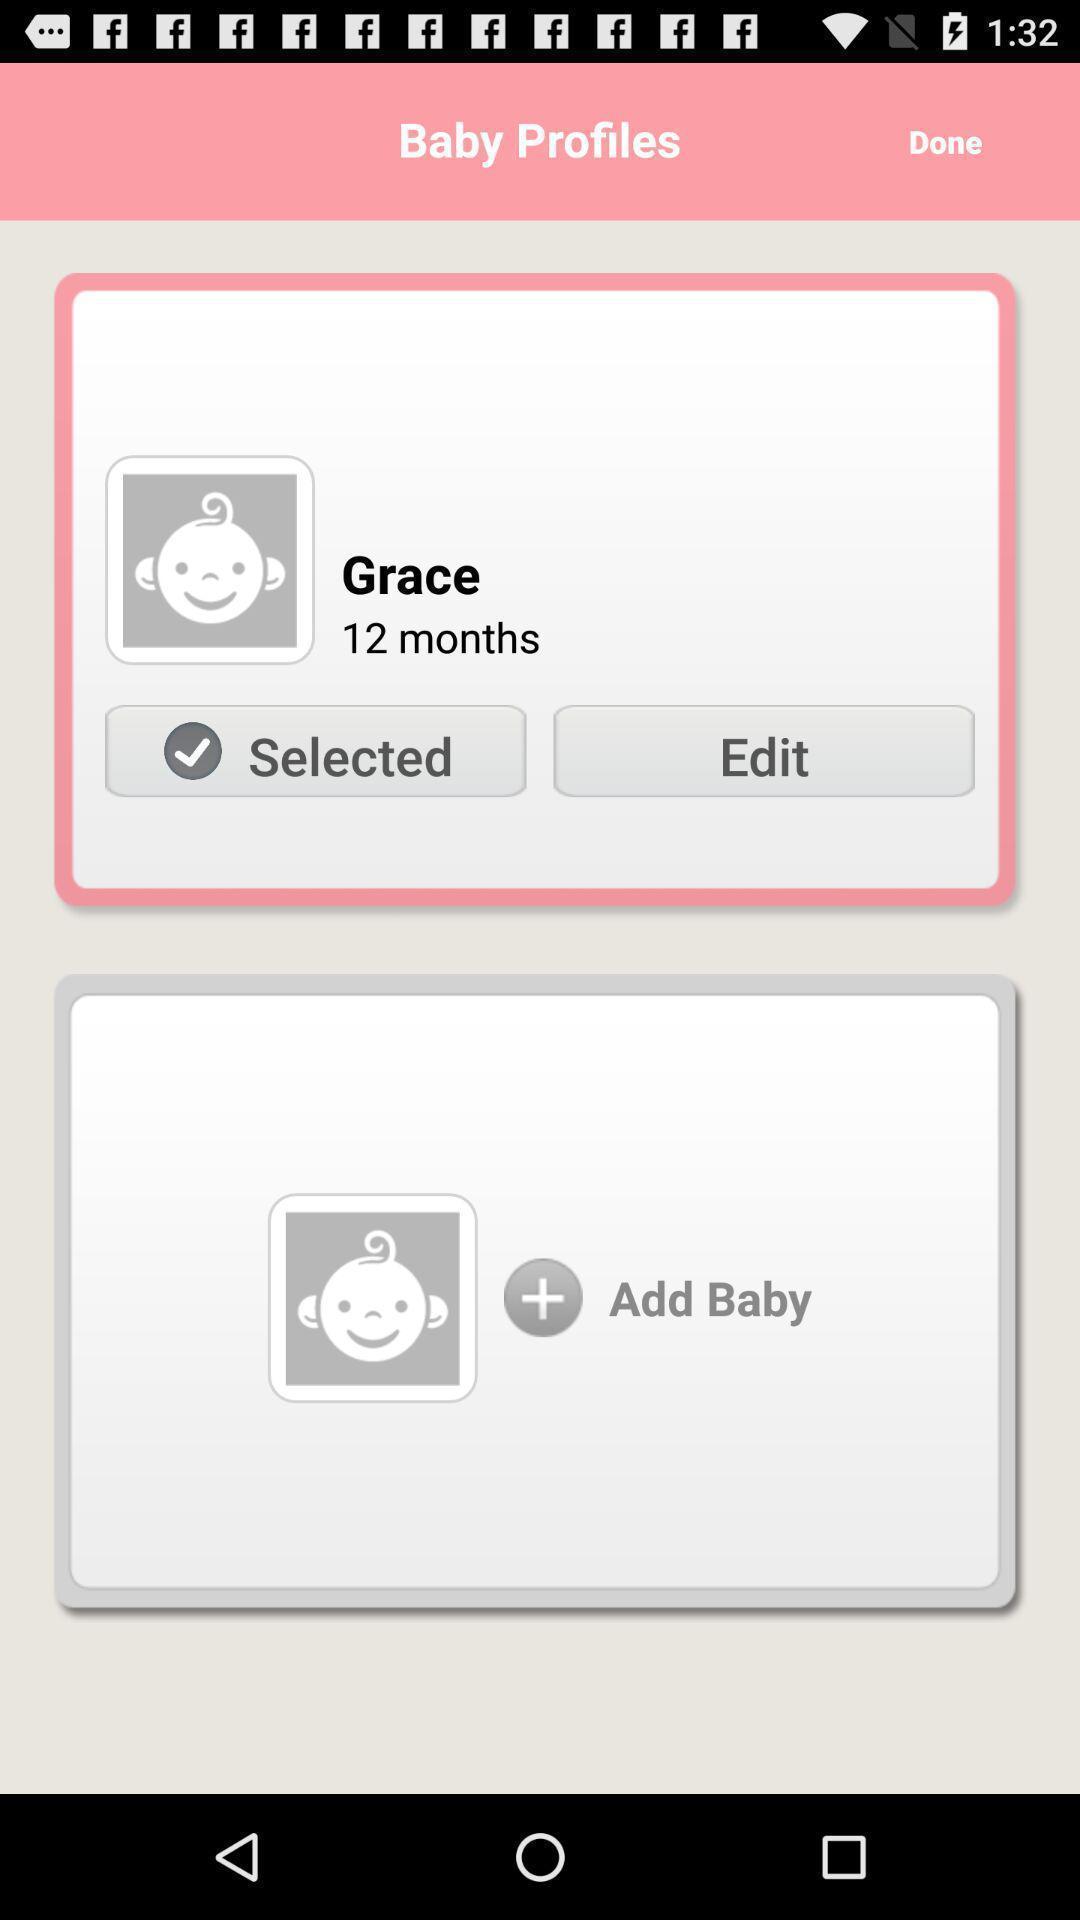Describe the visual elements of this screenshot. Screen displaying the baby profile. 